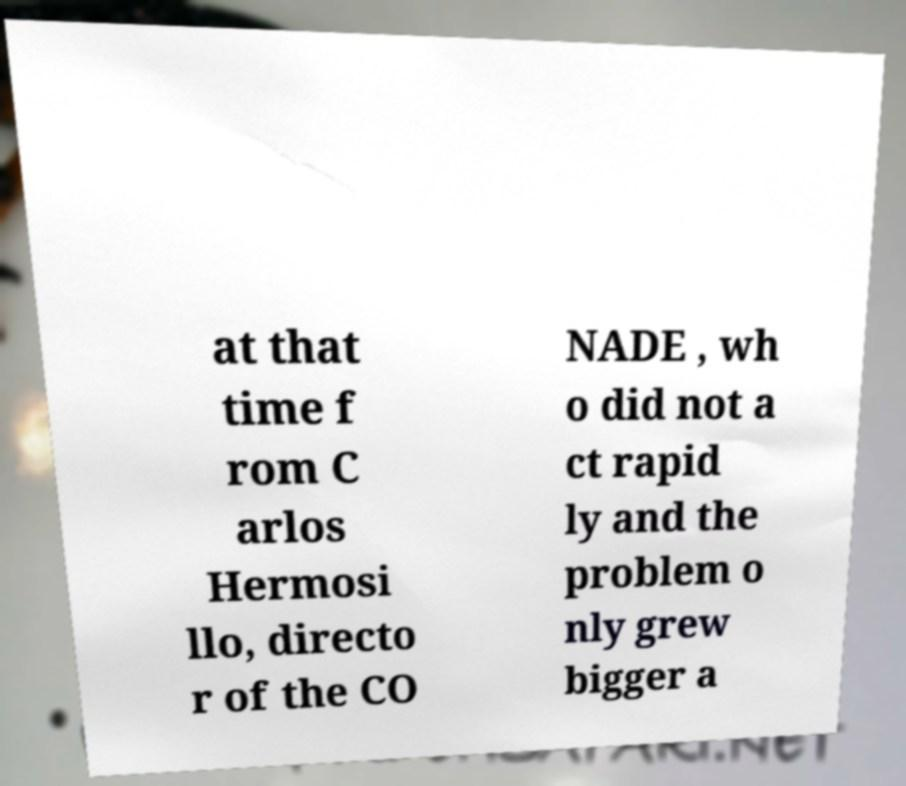There's text embedded in this image that I need extracted. Can you transcribe it verbatim? at that time f rom C arlos Hermosi llo, directo r of the CO NADE , wh o did not a ct rapid ly and the problem o nly grew bigger a 